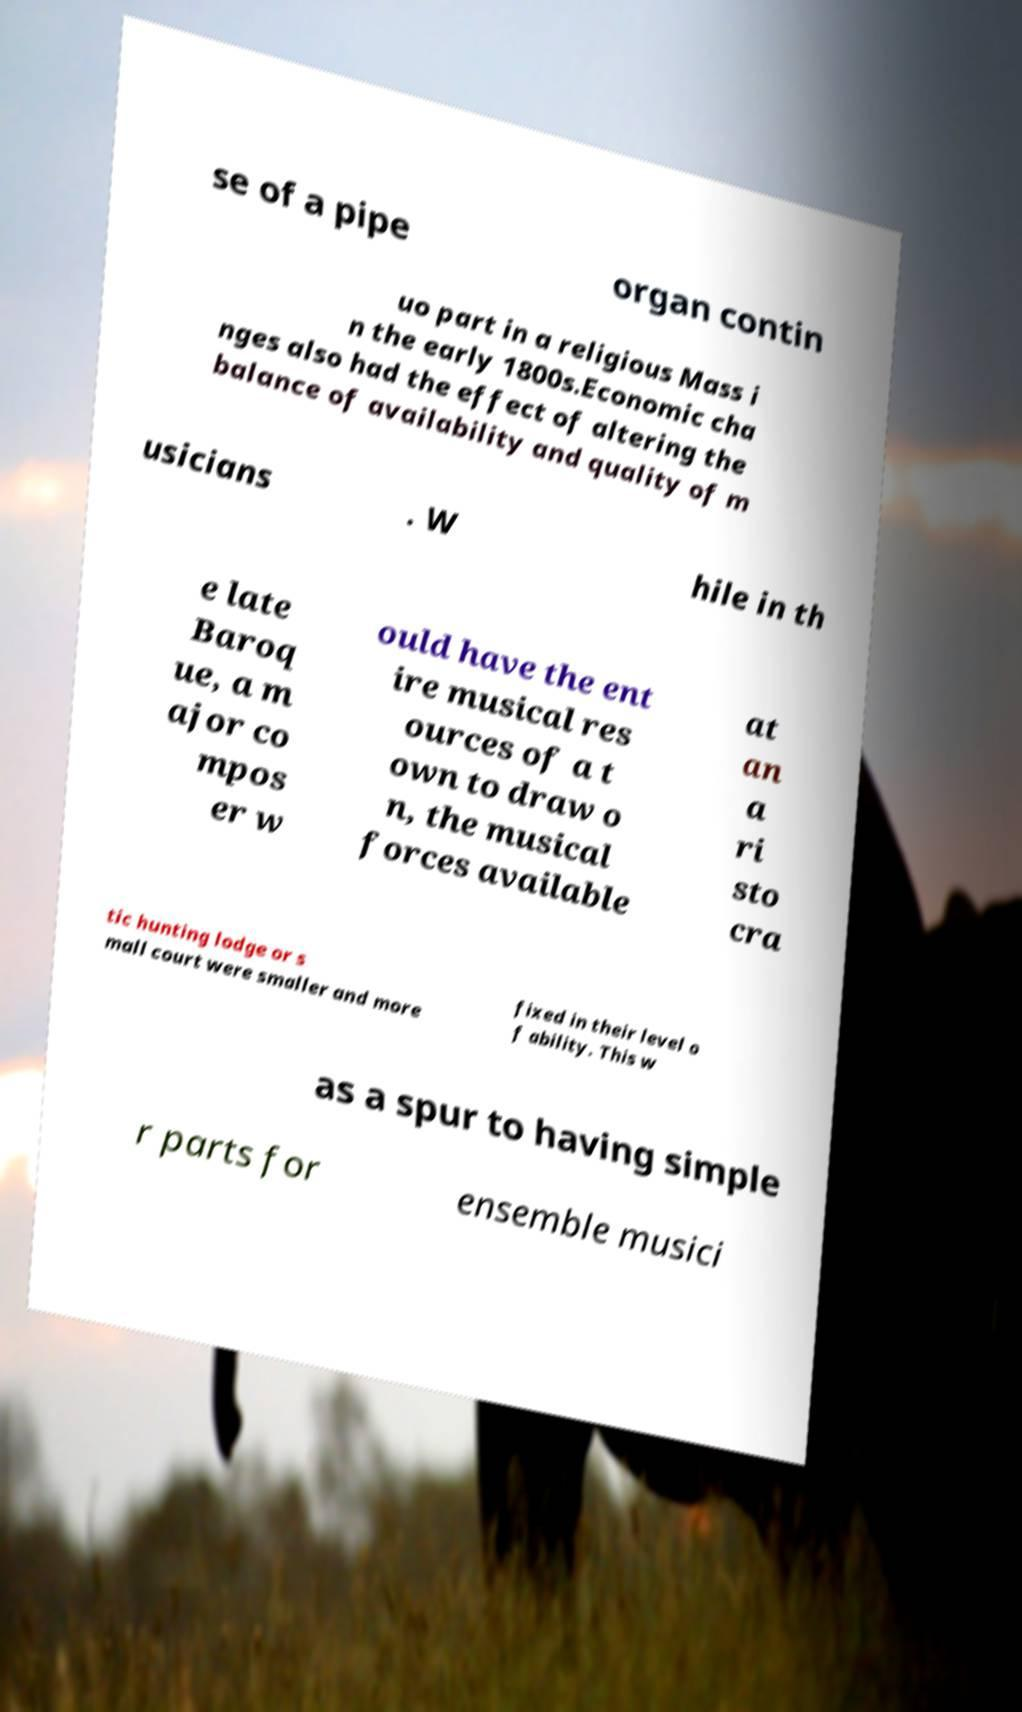For documentation purposes, I need the text within this image transcribed. Could you provide that? se of a pipe organ contin uo part in a religious Mass i n the early 1800s.Economic cha nges also had the effect of altering the balance of availability and quality of m usicians . W hile in th e late Baroq ue, a m ajor co mpos er w ould have the ent ire musical res ources of a t own to draw o n, the musical forces available at an a ri sto cra tic hunting lodge or s mall court were smaller and more fixed in their level o f ability. This w as a spur to having simple r parts for ensemble musici 